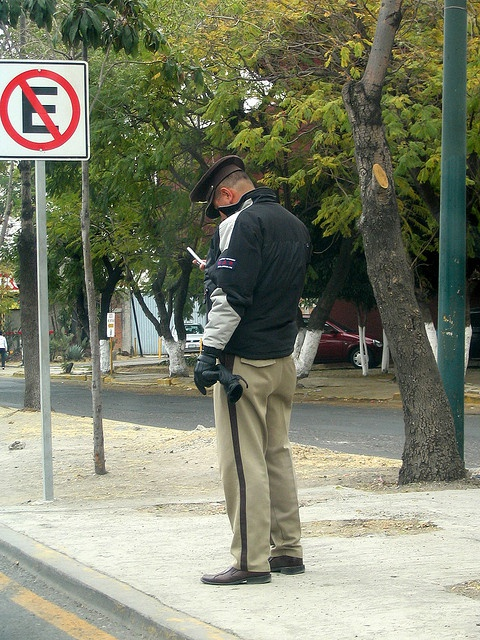Describe the objects in this image and their specific colors. I can see people in black, gray, and darkgray tones, car in black, gray, maroon, and darkgray tones, car in black, white, gray, and darkgray tones, people in black, white, purple, and darkblue tones, and cell phone in black, white, darkgray, and gray tones in this image. 